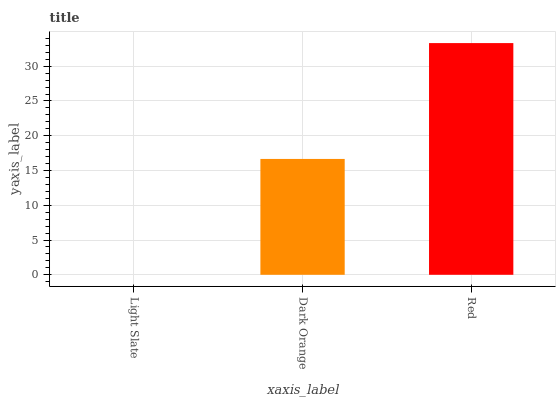Is Light Slate the minimum?
Answer yes or no. Yes. Is Red the maximum?
Answer yes or no. Yes. Is Dark Orange the minimum?
Answer yes or no. No. Is Dark Orange the maximum?
Answer yes or no. No. Is Dark Orange greater than Light Slate?
Answer yes or no. Yes. Is Light Slate less than Dark Orange?
Answer yes or no. Yes. Is Light Slate greater than Dark Orange?
Answer yes or no. No. Is Dark Orange less than Light Slate?
Answer yes or no. No. Is Dark Orange the high median?
Answer yes or no. Yes. Is Dark Orange the low median?
Answer yes or no. Yes. Is Light Slate the high median?
Answer yes or no. No. Is Red the low median?
Answer yes or no. No. 